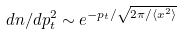<formula> <loc_0><loc_0><loc_500><loc_500>d n / d { p _ { t } ^ { 2 } } \sim e ^ { - p _ { t } / \sqrt { 2 \pi / \langle x ^ { 2 } \rangle } }</formula> 